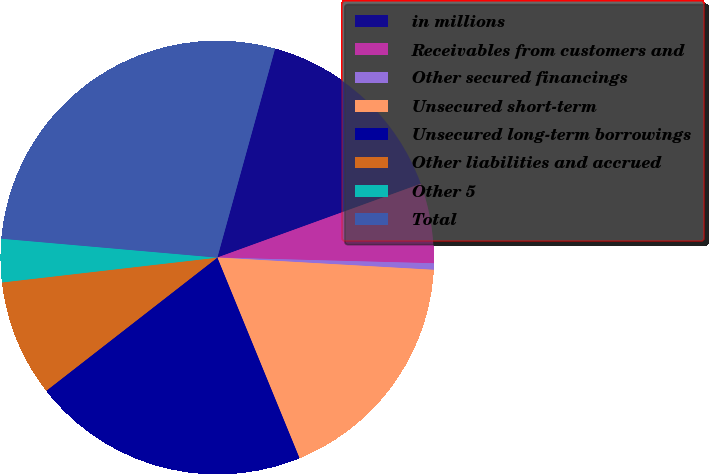Convert chart to OTSL. <chart><loc_0><loc_0><loc_500><loc_500><pie_chart><fcel>in millions<fcel>Receivables from customers and<fcel>Other secured financings<fcel>Unsecured short-term<fcel>Unsecured long-term borrowings<fcel>Other liabilities and accrued<fcel>Other 5<fcel>Total<nl><fcel>15.17%<fcel>5.96%<fcel>0.48%<fcel>17.91%<fcel>20.66%<fcel>8.7%<fcel>3.22%<fcel>27.9%<nl></chart> 